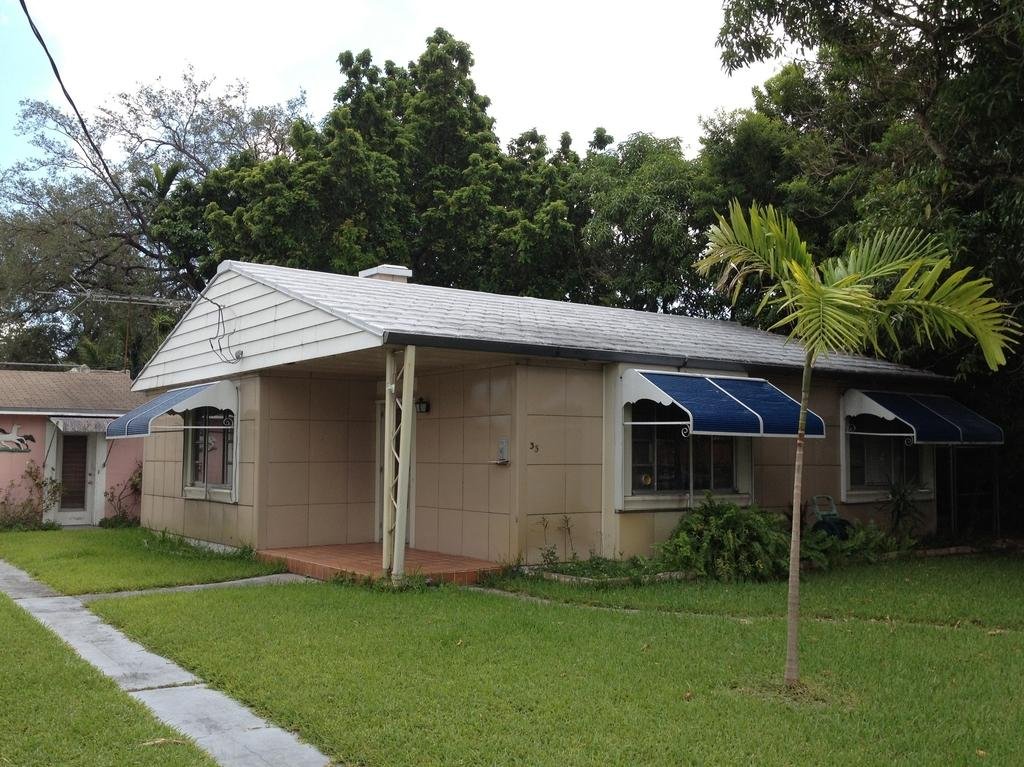What type of vegetation is present in the image? There is grass in the image. What type of structures can be seen in the image? There are houses in the image. What can be seen in the background of the image? There are trees and the sky visible in the background of the image. What is the name of the canvas on which the houses are painted in the image? There is no canvas present in the image; it is a photograph or illustration of real structures. How many points are visible on the grass in the image? The grass in the image is a continuous surface and does not have individual points. 